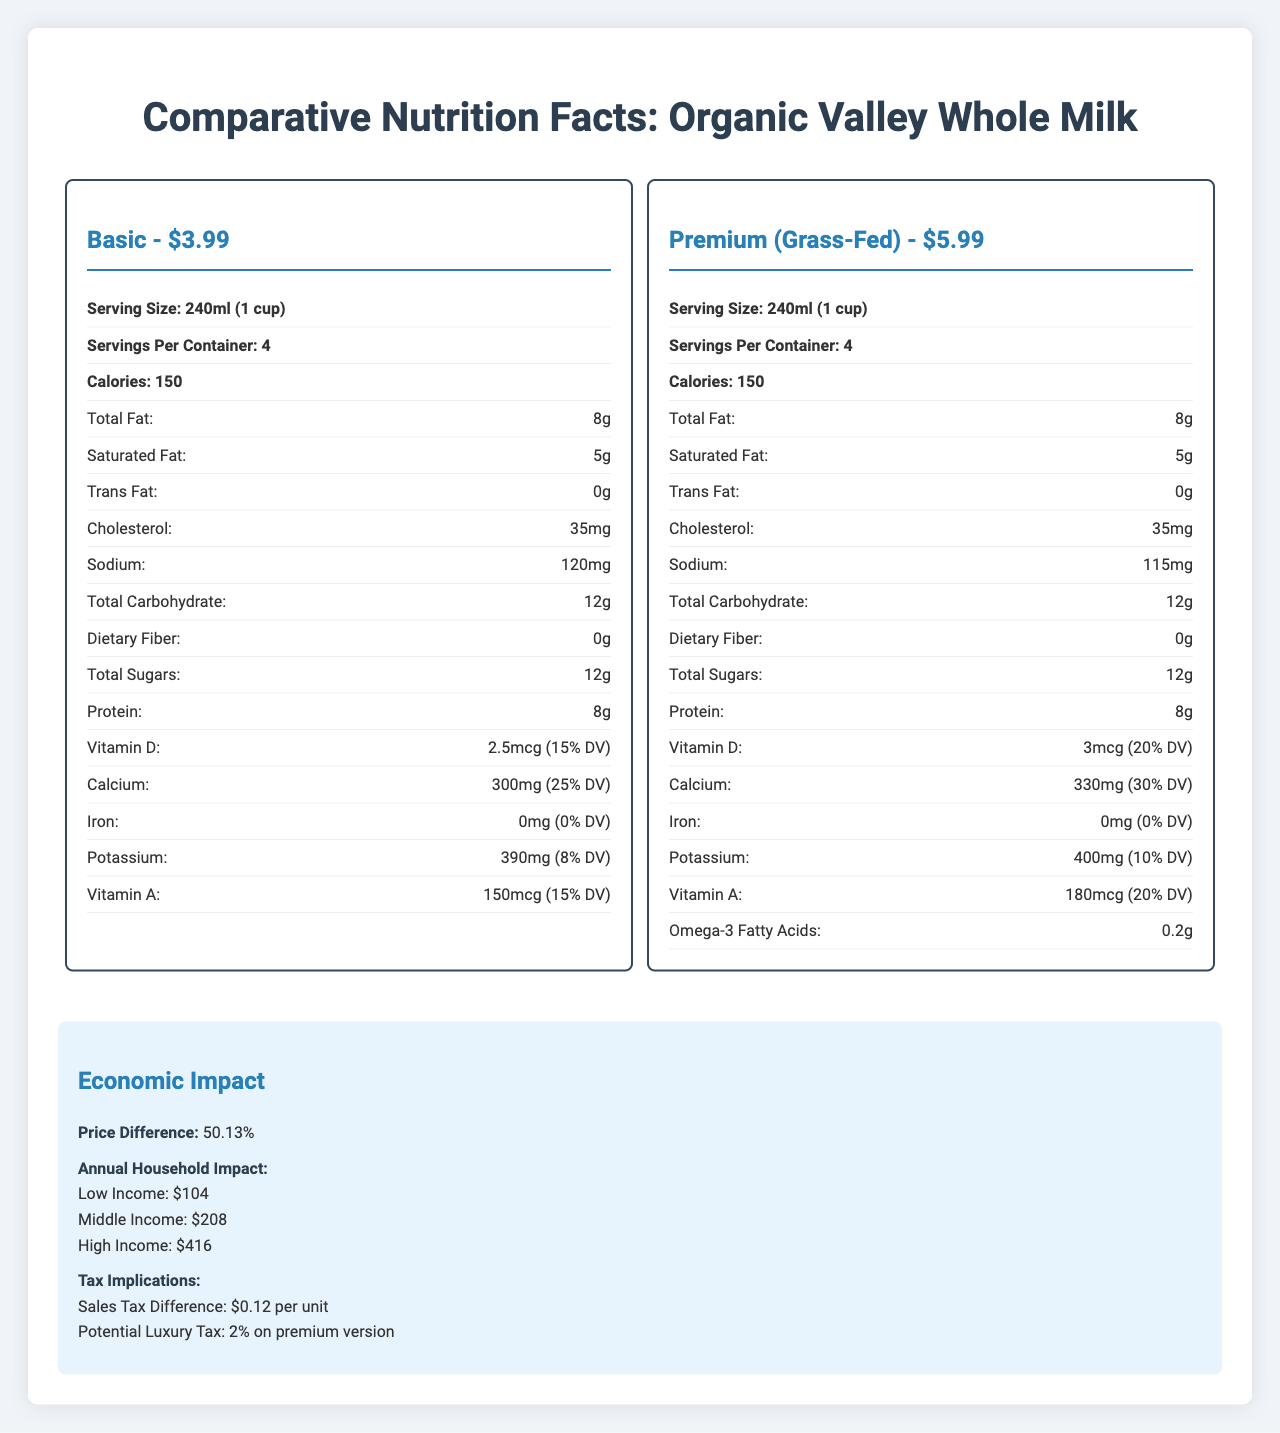what are the serving sizes of the basic and premium versions? The document states that both the basic and premium versions of milk have a serving size of 240ml (1 cup).
Answer: 240ml (1 cup) each how much protein do both versions contain per serving? The nutrition labels for both the basic and premium versions show that they each contain 8g of protein per serving.
Answer: 8g what is the price difference between the basic and premium versions? The basic version costs $3.99, while the premium version costs $5.99, resulting in a $2.00 difference.
Answer: $2.00 which version has a higher calcium content? The premium version contains 330mg (30% DV) of calcium, while the basic version contains 300mg (25% DV) of calcium.
Answer: Premium which demographic is more likely to purchase the basic version? The market analysis indicates that predominantly lower and middle-income households are more likely to purchase the basic version.
Answer: Predominantly lower and middle-income households how many servings per container are there in each version? A. 2 B. 4 C. 6 D. 8 Both the basic and premium versions have 4 servings per container as stated in the document.
Answer: B what is the percentage of daily value (%DV) of vitamin D in the premium version? i. 10% ii. 15% iii. 20% iv. 25% The premium version of the milk provides 3mcg of vitamin D, which is 20% of the daily value.
Answer: iii. 20% is there any iron in the milk products? Both the basic and premium versions have 0mg of iron listed in their nutritional information.
Answer: No describe the main idea of the document. The document provides a detailed comparison of the basic and premium versions of the milk product, including their nutritional content, price differences, economic impact on various income households, consumption trends based on consumer demographics, and potential health benefits. Additionally, it discusses policy considerations that may affect the affordability and promotion of these milk products.
Answer: The document compares the nutrition facts, market and economic impacts, health implications, and policy considerations of basic vs. premium (grass-fed) versions of Organic Valley Whole Milk. how old are the consumers who prefer the premium version? The document does not provide specific age data about consumers who prefer the premium version.
Answer: Not enough information what potential tax implications are mentioned for the premium version? The document mentions a sales tax difference of $0.12 per unit and a potential luxury tax of 2% on the premium version of the milk.
Answer: Sales tax difference of $0.12 per unit and potential luxury tax of 2% 